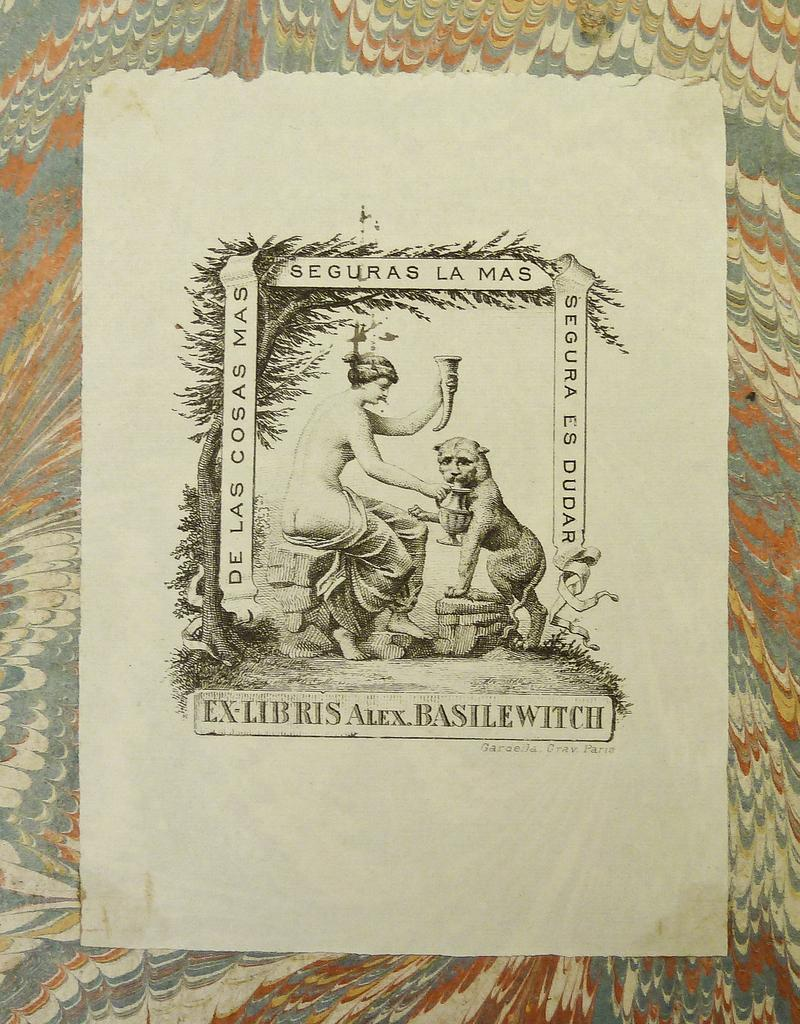<image>
Create a compact narrative representing the image presented. a sign for Ex Libris Alex Basilewitch shows a woman and a cat 